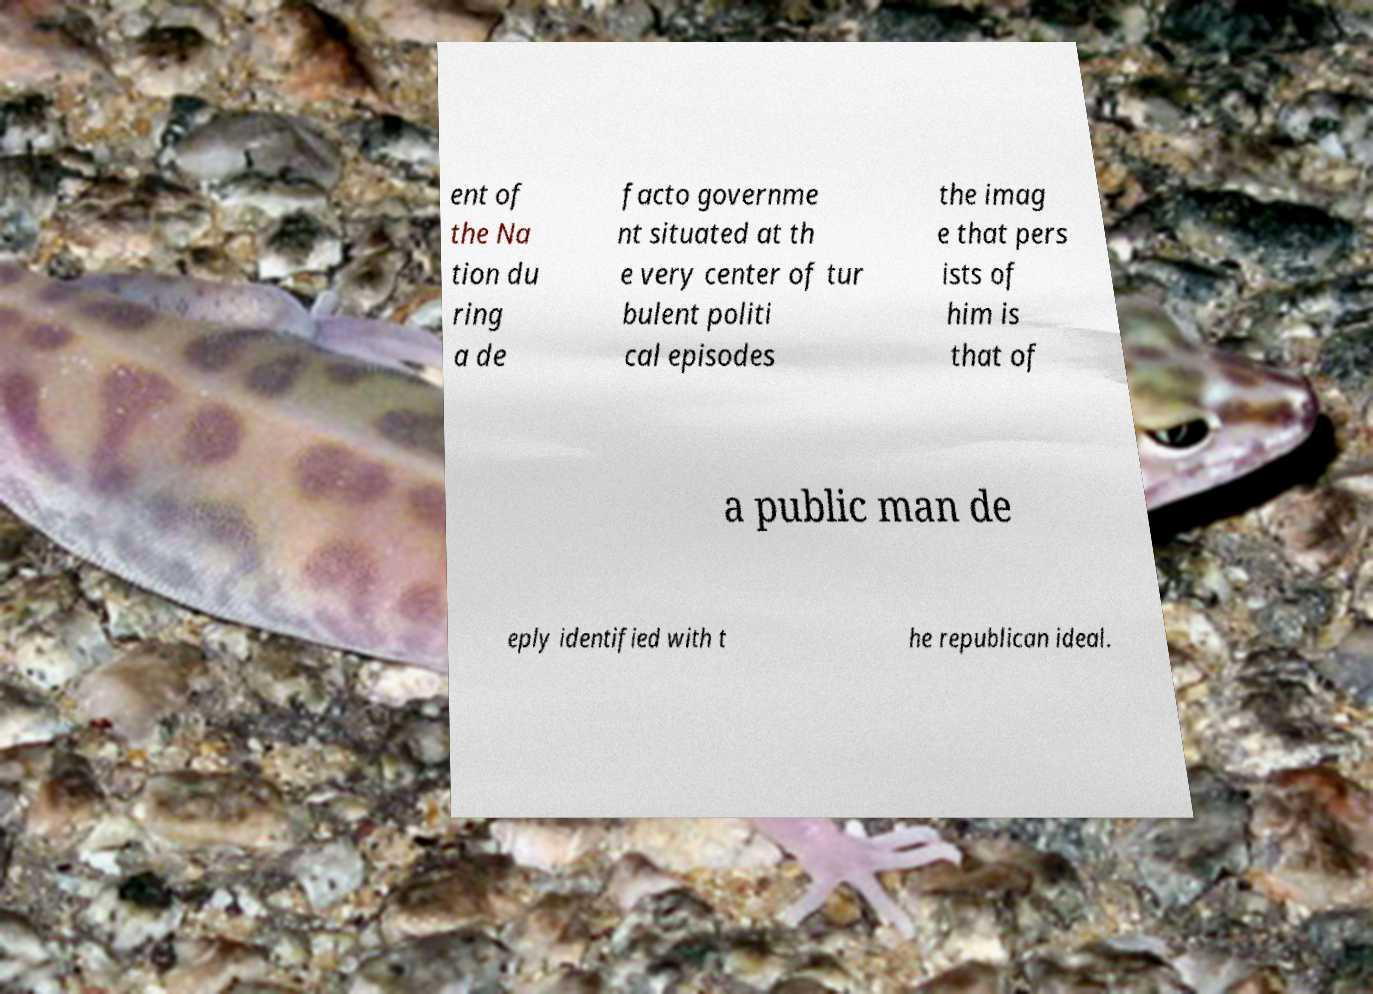What messages or text are displayed in this image? I need them in a readable, typed format. ent of the Na tion du ring a de facto governme nt situated at th e very center of tur bulent politi cal episodes the imag e that pers ists of him is that of a public man de eply identified with t he republican ideal. 